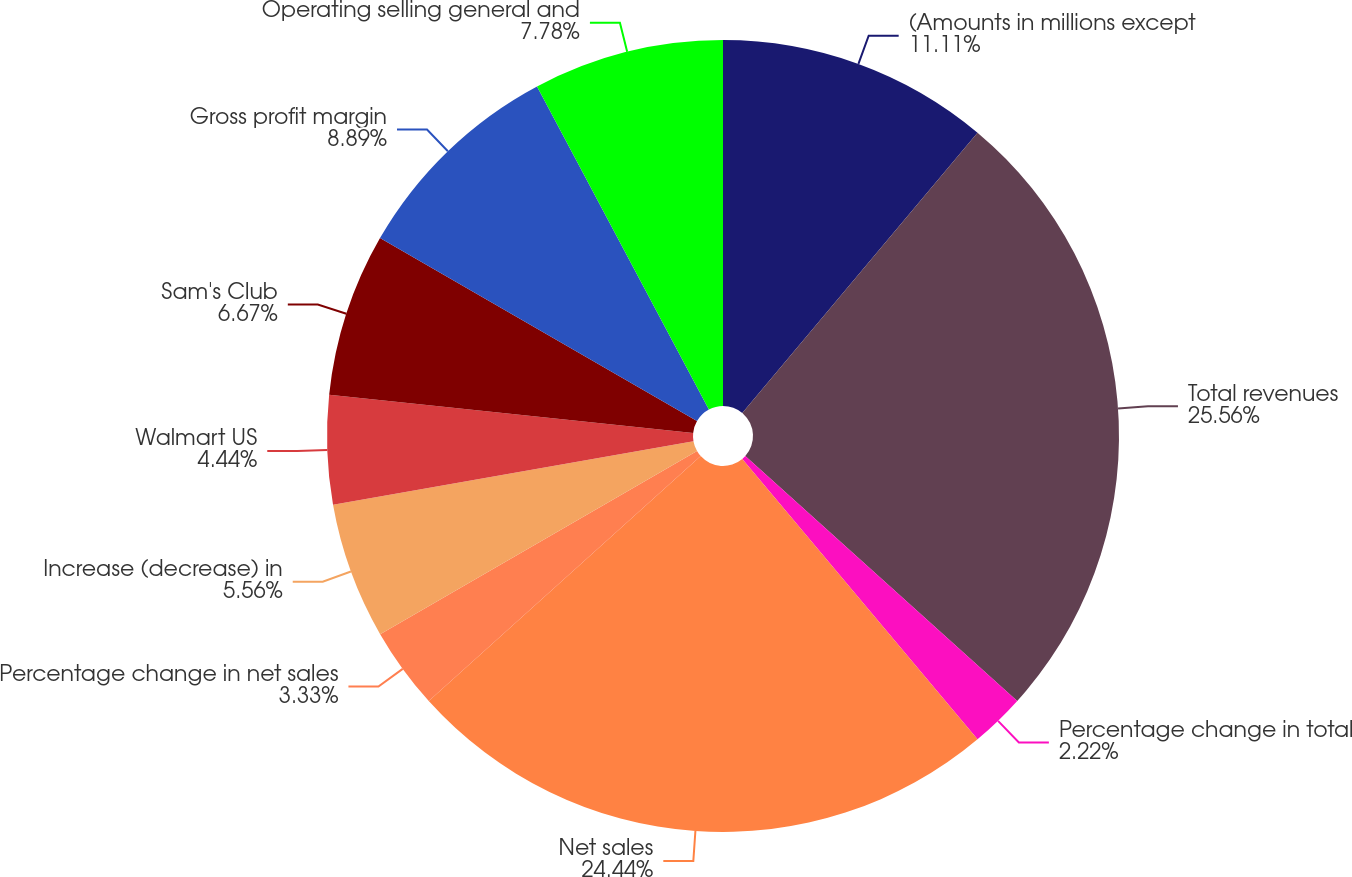Convert chart to OTSL. <chart><loc_0><loc_0><loc_500><loc_500><pie_chart><fcel>(Amounts in millions except<fcel>Total revenues<fcel>Percentage change in total<fcel>Net sales<fcel>Percentage change in net sales<fcel>Increase (decrease) in<fcel>Walmart US<fcel>Sam's Club<fcel>Gross profit margin<fcel>Operating selling general and<nl><fcel>11.11%<fcel>25.56%<fcel>2.22%<fcel>24.44%<fcel>3.33%<fcel>5.56%<fcel>4.44%<fcel>6.67%<fcel>8.89%<fcel>7.78%<nl></chart> 